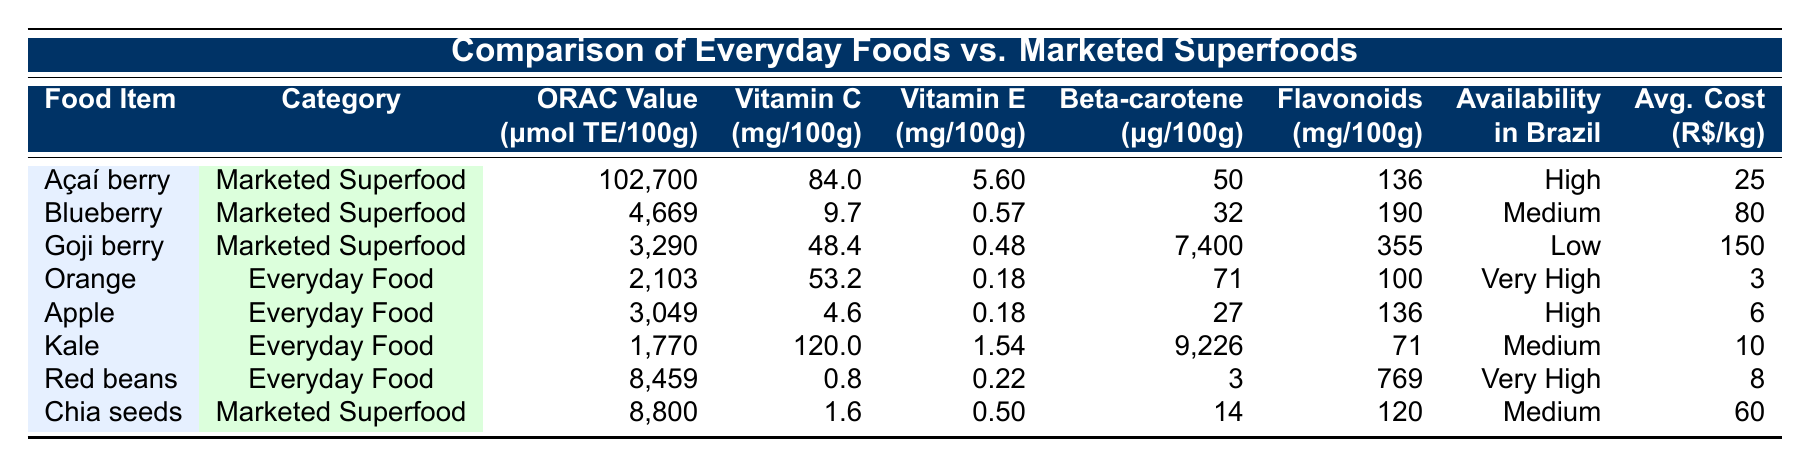What is the ORAC value of Açaí berry? The table shows the ORAC value of Açaí berry listed as 102,700 μmol TE/100g.
Answer: 102,700 Which food item has the highest Vitamin C content? By examining the Vitamin C column, Kale shows the highest value at 120 mg/100g.
Answer: Kale Are Goji berries highly available in Brazil? The availability status for Goji berries is marked as "Low" in the table, which means they are not highly available.
Answer: No What is the average cost of marketed superfoods listed? The costs for marketed superfoods are 25, 80, 150, and 60 R$/kg. Summing these values gives 315, and dividing by 4 results in an average of 78.75.
Answer: 78.75 Does Red beans have a higher ORAC value than Chia seeds? The ORAC value for Red beans is 8,459 and for Chia seeds is 8,800. Since 8,459 is less than 8,800, Red beans do not have a higher value.
Answer: No What is the total Vitamin E content in everyday foods? The Vitamin E values for everyday foods are 0.18, 0.18, 1.54, and 0.22 mg/100g. Adding these gives 0.18 + 0.18 + 1.54 + 0.22 = 2.12 mg/100g.
Answer: 2.12 Which food item has the most Flavonoids? By comparing the Flavonoids column, Goji berries have the highest amount at 355 mg/100g.
Answer: Goji berry Calculate the difference in ORAC values between Açaí berry and Orange. The ORAC value for Açaí berry is 102,700 μmol TE/100g and for Orange is 2,103 μmol TE/100g. The difference is calculated as 102,700 - 2,103 = 100,597.
Answer: 100,597 